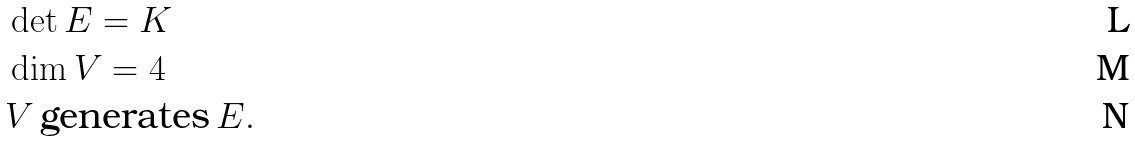<formula> <loc_0><loc_0><loc_500><loc_500>& \det E = K \\ & \dim V = 4 \\ & V \, \text {generates} \, E .</formula> 